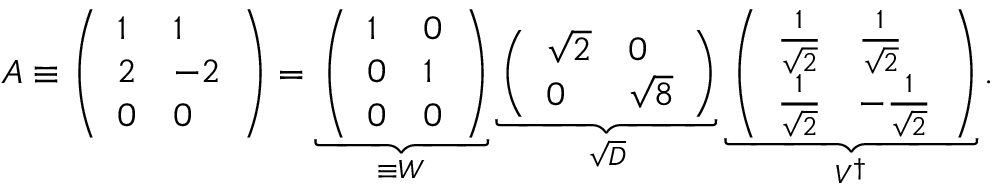<formula> <loc_0><loc_0><loc_500><loc_500>A \equiv \left ( \begin{array} { l l } { 1 } & { 1 } \\ { 2 } & { - 2 } \\ { 0 } & { 0 } \end{array} \right ) = \underbrace { \left ( \begin{array} { l l } { 1 } & { 0 } \\ { 0 } & { 1 } \\ { 0 } & { 0 } \end{array} \right ) } _ { \equiv W } \underbrace { \left ( \begin{array} { l l } { { \sqrt { 2 } } } & { 0 } \\ { 0 } & { { \sqrt { 8 } } } \end{array} \right ) } _ { \sqrt { D } } \underbrace { \left ( \begin{array} { l l } { { \frac { 1 } { \sqrt { 2 } } } } & { { \frac { 1 } { \sqrt { 2 } } } } \\ { { \frac { 1 } { \sqrt { 2 } } } } & { - { \frac { 1 } { \sqrt { 2 } } } } \end{array} \right ) } _ { V ^ { \dagger } } .</formula> 